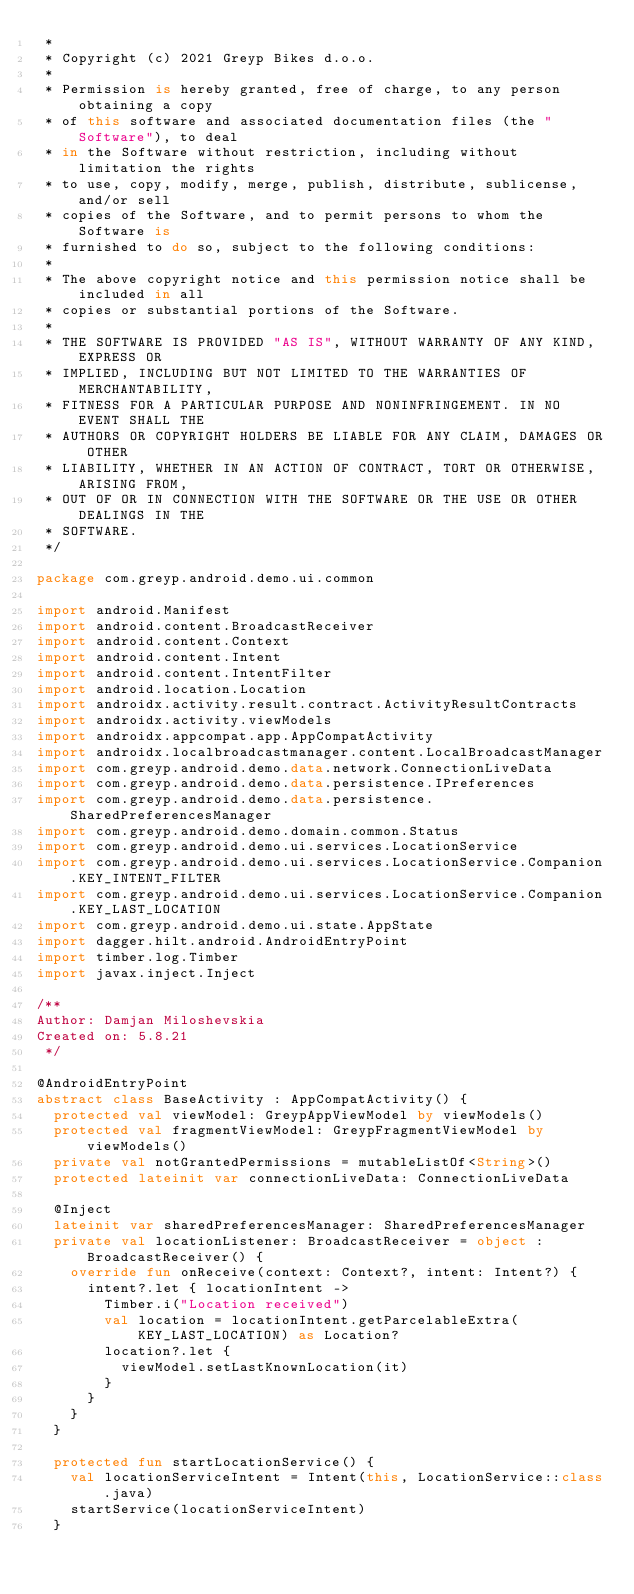<code> <loc_0><loc_0><loc_500><loc_500><_Kotlin_> *
 * Copyright (c) 2021 Greyp Bikes d.o.o.
 *
 * Permission is hereby granted, free of charge, to any person obtaining a copy
 * of this software and associated documentation files (the "Software"), to deal
 * in the Software without restriction, including without limitation the rights
 * to use, copy, modify, merge, publish, distribute, sublicense, and/or sell
 * copies of the Software, and to permit persons to whom the Software is
 * furnished to do so, subject to the following conditions:
 *
 * The above copyright notice and this permission notice shall be included in all
 * copies or substantial portions of the Software.
 *
 * THE SOFTWARE IS PROVIDED "AS IS", WITHOUT WARRANTY OF ANY KIND, EXPRESS OR
 * IMPLIED, INCLUDING BUT NOT LIMITED TO THE WARRANTIES OF MERCHANTABILITY,
 * FITNESS FOR A PARTICULAR PURPOSE AND NONINFRINGEMENT. IN NO EVENT SHALL THE
 * AUTHORS OR COPYRIGHT HOLDERS BE LIABLE FOR ANY CLAIM, DAMAGES OR OTHER
 * LIABILITY, WHETHER IN AN ACTION OF CONTRACT, TORT OR OTHERWISE, ARISING FROM,
 * OUT OF OR IN CONNECTION WITH THE SOFTWARE OR THE USE OR OTHER DEALINGS IN THE
 * SOFTWARE.
 */

package com.greyp.android.demo.ui.common

import android.Manifest
import android.content.BroadcastReceiver
import android.content.Context
import android.content.Intent
import android.content.IntentFilter
import android.location.Location
import androidx.activity.result.contract.ActivityResultContracts
import androidx.activity.viewModels
import androidx.appcompat.app.AppCompatActivity
import androidx.localbroadcastmanager.content.LocalBroadcastManager
import com.greyp.android.demo.data.network.ConnectionLiveData
import com.greyp.android.demo.data.persistence.IPreferences
import com.greyp.android.demo.data.persistence.SharedPreferencesManager
import com.greyp.android.demo.domain.common.Status
import com.greyp.android.demo.ui.services.LocationService
import com.greyp.android.demo.ui.services.LocationService.Companion.KEY_INTENT_FILTER
import com.greyp.android.demo.ui.services.LocationService.Companion.KEY_LAST_LOCATION
import com.greyp.android.demo.ui.state.AppState
import dagger.hilt.android.AndroidEntryPoint
import timber.log.Timber
import javax.inject.Inject

/**
Author: Damjan Miloshevskia
Created on: 5.8.21
 */

@AndroidEntryPoint
abstract class BaseActivity : AppCompatActivity() {
  protected val viewModel: GreypAppViewModel by viewModels()
  protected val fragmentViewModel: GreypFragmentViewModel by viewModels()
  private val notGrantedPermissions = mutableListOf<String>()
  protected lateinit var connectionLiveData: ConnectionLiveData

  @Inject
  lateinit var sharedPreferencesManager: SharedPreferencesManager
  private val locationListener: BroadcastReceiver = object : BroadcastReceiver() {
    override fun onReceive(context: Context?, intent: Intent?) {
      intent?.let { locationIntent ->
        Timber.i("Location received")
        val location = locationIntent.getParcelableExtra(KEY_LAST_LOCATION) as Location?
        location?.let {
          viewModel.setLastKnownLocation(it)
        }
      }
    }
  }

  protected fun startLocationService() {
    val locationServiceIntent = Intent(this, LocationService::class.java)
    startService(locationServiceIntent)
  }
</code> 